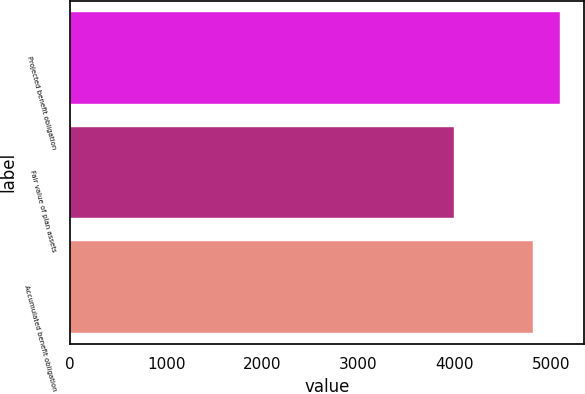Convert chart. <chart><loc_0><loc_0><loc_500><loc_500><bar_chart><fcel>Projected benefit obligation<fcel>Fair value of plan assets<fcel>Accumulated benefit obligation<nl><fcel>5093<fcel>3996<fcel>4812<nl></chart> 